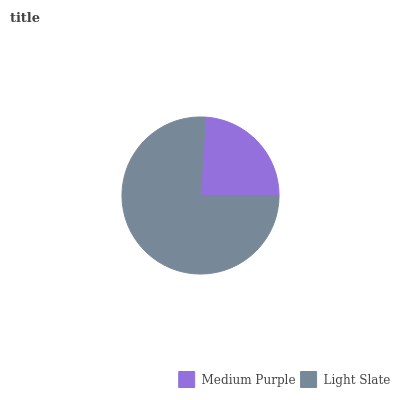Is Medium Purple the minimum?
Answer yes or no. Yes. Is Light Slate the maximum?
Answer yes or no. Yes. Is Light Slate the minimum?
Answer yes or no. No. Is Light Slate greater than Medium Purple?
Answer yes or no. Yes. Is Medium Purple less than Light Slate?
Answer yes or no. Yes. Is Medium Purple greater than Light Slate?
Answer yes or no. No. Is Light Slate less than Medium Purple?
Answer yes or no. No. Is Light Slate the high median?
Answer yes or no. Yes. Is Medium Purple the low median?
Answer yes or no. Yes. Is Medium Purple the high median?
Answer yes or no. No. Is Light Slate the low median?
Answer yes or no. No. 